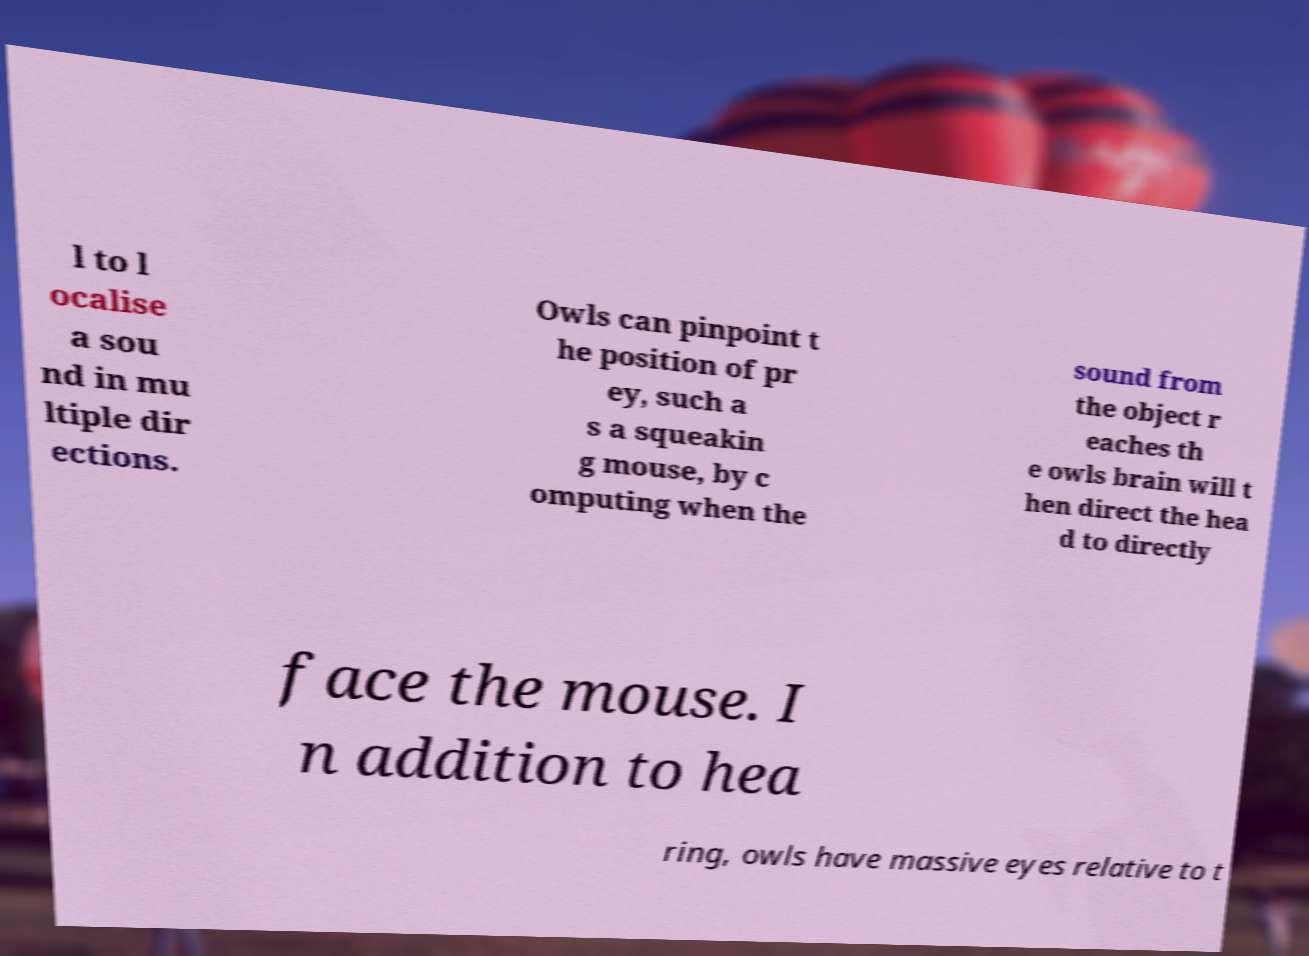Could you assist in decoding the text presented in this image and type it out clearly? l to l ocalise a sou nd in mu ltiple dir ections. Owls can pinpoint t he position of pr ey, such a s a squeakin g mouse, by c omputing when the sound from the object r eaches th e owls brain will t hen direct the hea d to directly face the mouse. I n addition to hea ring, owls have massive eyes relative to t 